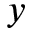<formula> <loc_0><loc_0><loc_500><loc_500>y</formula> 